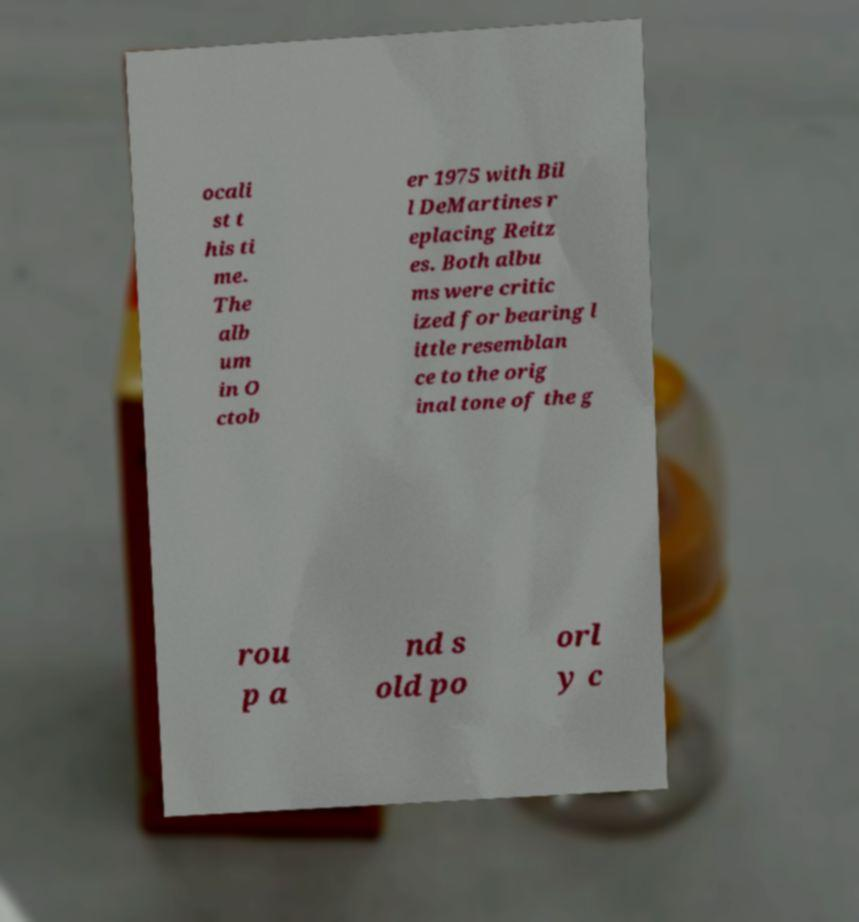Can you accurately transcribe the text from the provided image for me? ocali st t his ti me. The alb um in O ctob er 1975 with Bil l DeMartines r eplacing Reitz es. Both albu ms were critic ized for bearing l ittle resemblan ce to the orig inal tone of the g rou p a nd s old po orl y c 